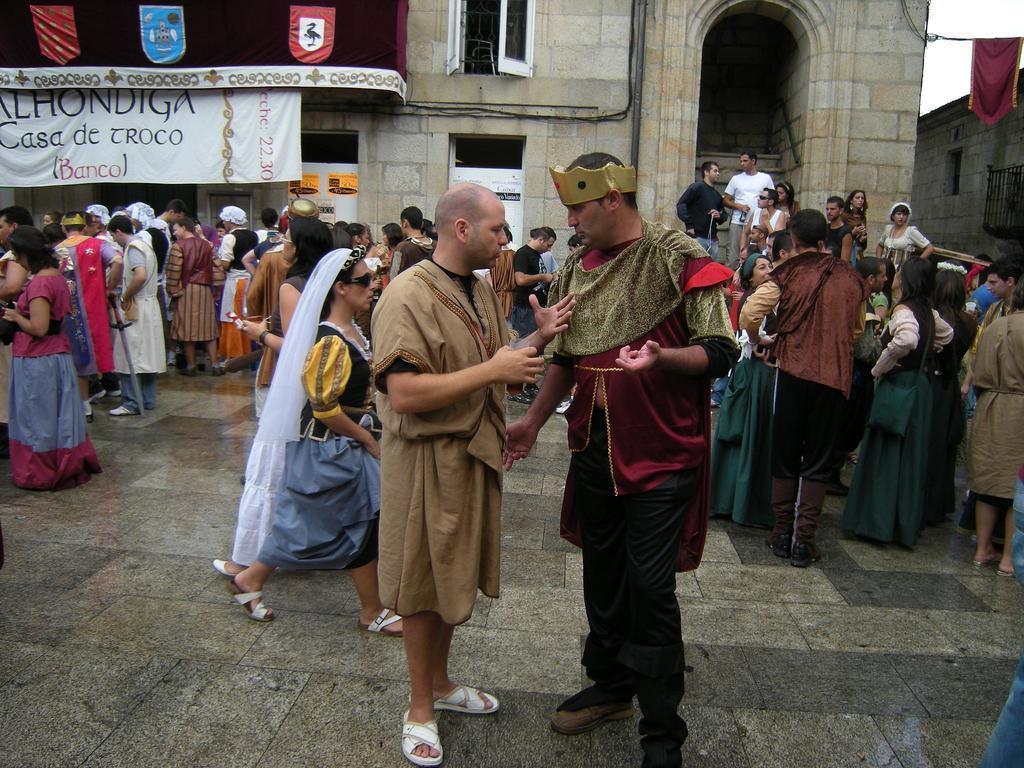Describe this image in one or two sentences. In this image in the foreground there are two persons wearing costumes, taking to each other , back side of them there are group of people visible , behind them there is a building , in the top left there is a banner, on the banner there is a text visible. 